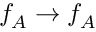Convert formula to latex. <formula><loc_0><loc_0><loc_500><loc_500>f _ { A } \rightarrow f _ { A }</formula> 